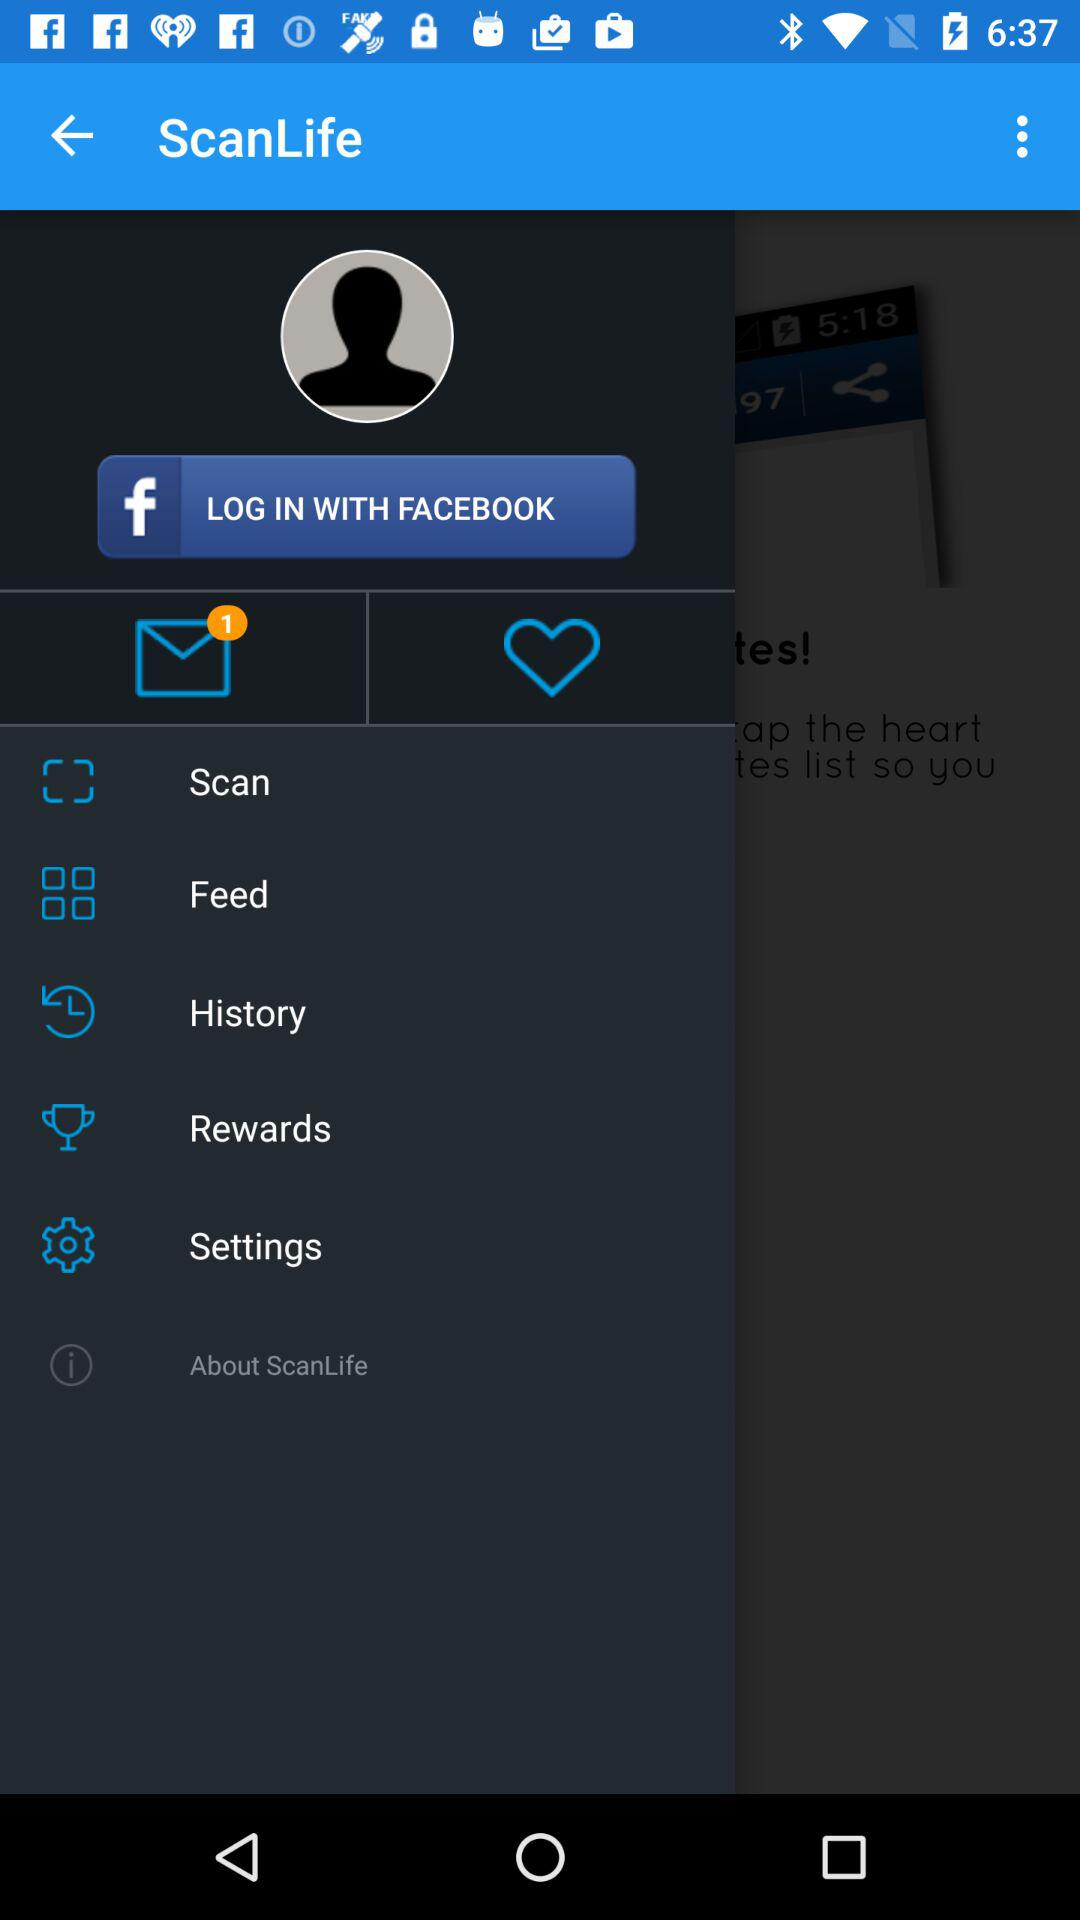Which tab is currently selected?
When the provided information is insufficient, respond with <no answer>. <no answer> 